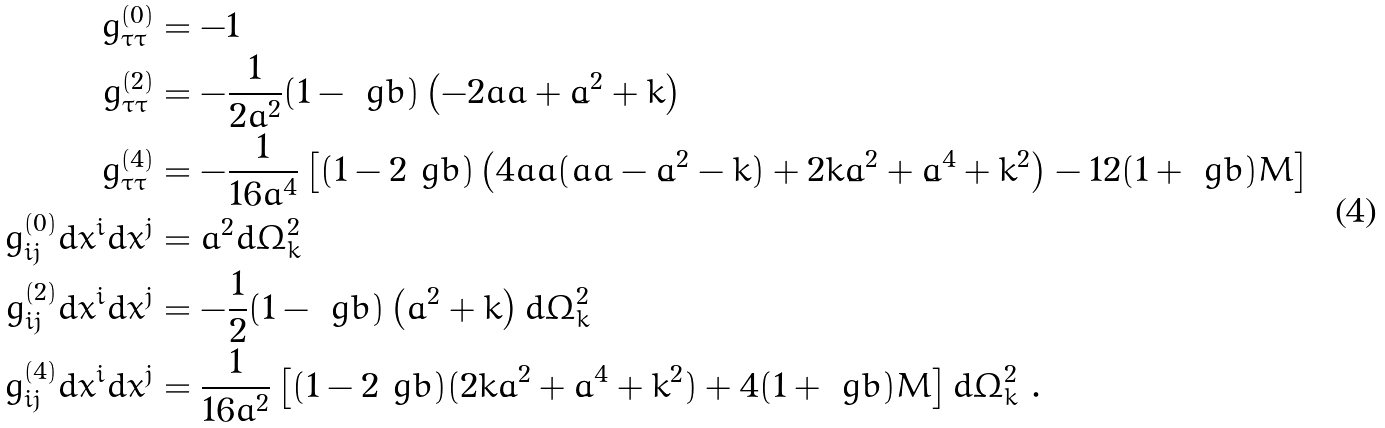<formula> <loc_0><loc_0><loc_500><loc_500>g _ { \tau \tau } ^ { ( 0 ) } & = - 1 \\ g _ { \tau \tau } ^ { ( 2 ) } & = - \frac { 1 } { 2 a ^ { 2 } } ( 1 - \ g b ) \left ( - 2 a \ddot { a } + \dot { a } ^ { 2 } + k \right ) \\ g _ { \tau \tau } ^ { ( 4 ) } & = - \frac { 1 } { 1 6 a ^ { 4 } } \left [ ( 1 - 2 \ g b ) \left ( 4 a \ddot { a } ( a \ddot { a } - \dot { a } ^ { 2 } - k ) + 2 k \dot { a } ^ { 2 } + \dot { a } ^ { 4 } + k ^ { 2 } \right ) - 1 2 ( 1 + \ g b ) M \right ] \\ g _ { i j } ^ { ( 0 ) } d x ^ { i } d x ^ { j } & = a ^ { 2 } d \Omega _ { k } ^ { 2 } \\ g _ { i j } ^ { ( 2 ) } d x ^ { i } d x ^ { j } & = - \frac { 1 } { 2 } ( 1 - \ g b ) \left ( \dot { a } ^ { 2 } + k \right ) d \Omega _ { k } ^ { 2 } \\ g _ { i j } ^ { ( 4 ) } d x ^ { i } d x ^ { j } & = \frac { 1 } { 1 6 a ^ { 2 } } \left [ ( 1 - 2 \ g b ) ( 2 k \dot { a } ^ { 2 } + \dot { a } ^ { 4 } + k ^ { 2 } ) + 4 ( 1 + \ g b ) M \right ] d \Omega _ { k } ^ { 2 } \ .</formula> 